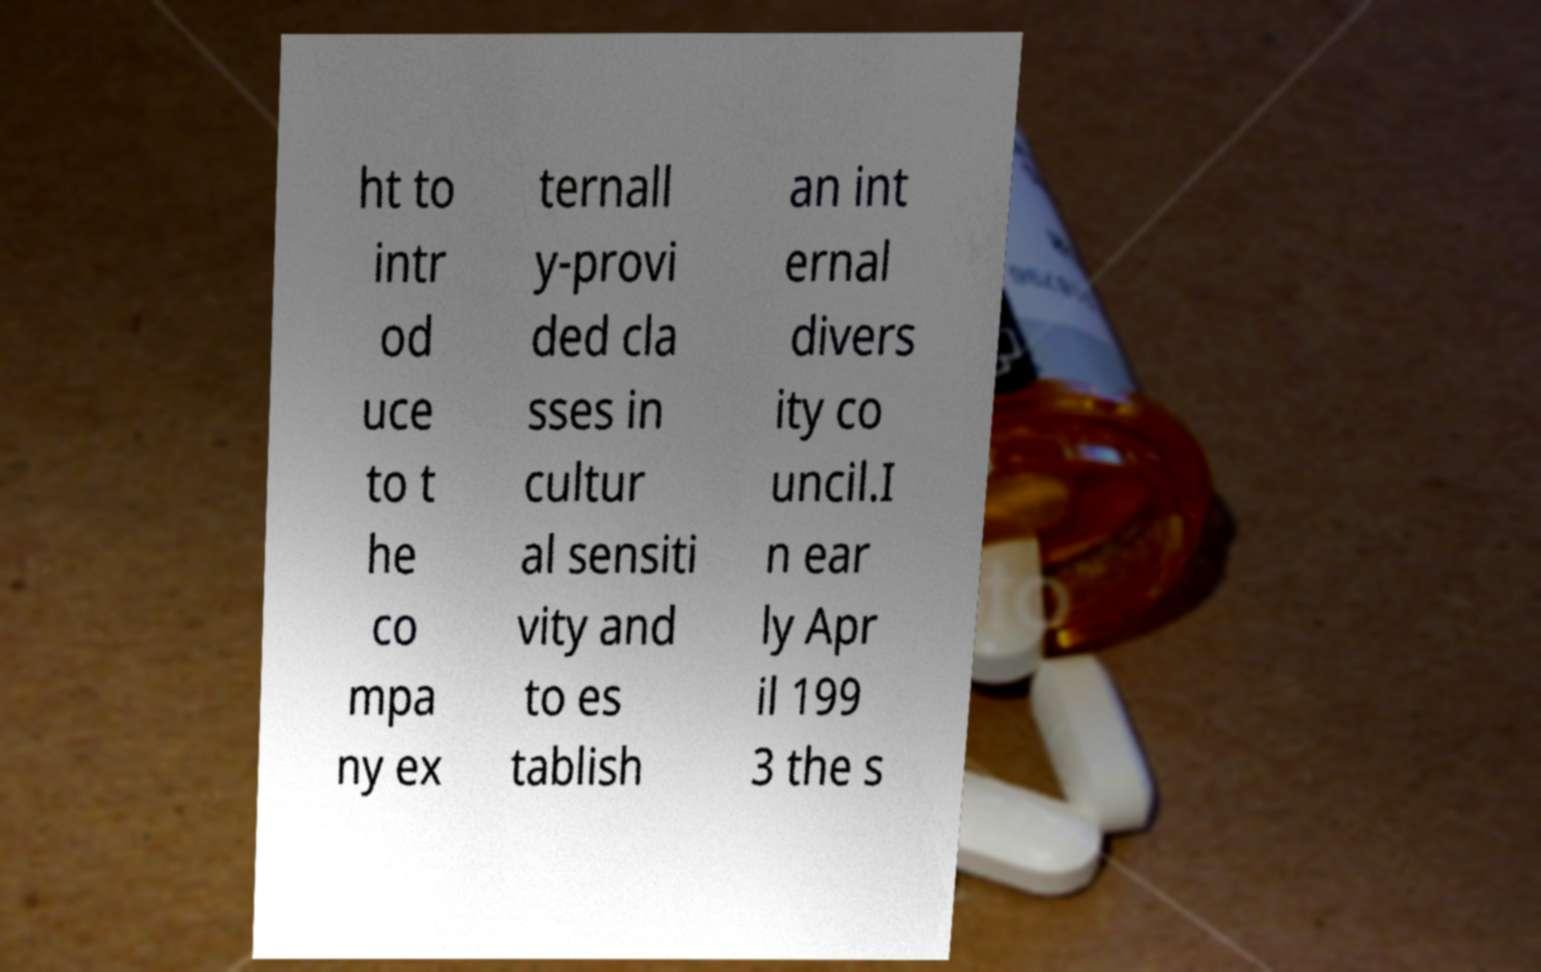Could you assist in decoding the text presented in this image and type it out clearly? ht to intr od uce to t he co mpa ny ex ternall y-provi ded cla sses in cultur al sensiti vity and to es tablish an int ernal divers ity co uncil.I n ear ly Apr il 199 3 the s 